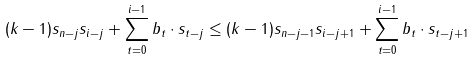Convert formula to latex. <formula><loc_0><loc_0><loc_500><loc_500>( k - 1 ) s _ { n - j } s _ { i - j } + \sum _ { t = 0 } ^ { i - 1 } b _ { t } \cdot s _ { t - j } \leq ( k - 1 ) s _ { n - j - 1 } s _ { i - j + 1 } + \sum _ { t = 0 } ^ { i - 1 } b _ { t } \cdot s _ { t - j + 1 }</formula> 